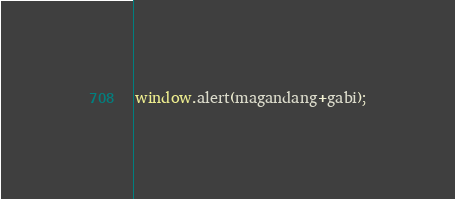<code> <loc_0><loc_0><loc_500><loc_500><_JavaScript_>window.alert(magandang+gabi);
</code> 